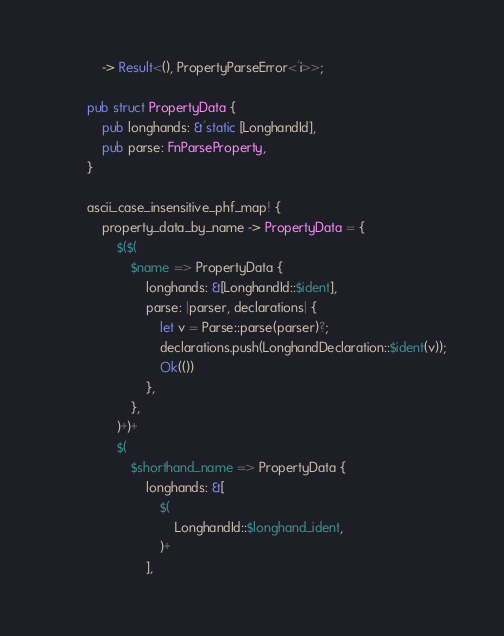<code> <loc_0><loc_0><loc_500><loc_500><_Rust_>            -> Result<(), PropertyParseError<'i>>;

        pub struct PropertyData {
            pub longhands: &'static [LonghandId],
            pub parse: FnParseProperty,
        }

        ascii_case_insensitive_phf_map! {
            property_data_by_name -> PropertyData = {
                $($(
                    $name => PropertyData {
                        longhands: &[LonghandId::$ident],
                        parse: |parser, declarations| {
                            let v = Parse::parse(parser)?;
                            declarations.push(LonghandDeclaration::$ident(v));
                            Ok(())
                        },
                    },
                )+)+
                $(
                    $shorthand_name => PropertyData {
                        longhands: &[
                            $(
                                LonghandId::$longhand_ident,
                            )+
                        ],</code> 